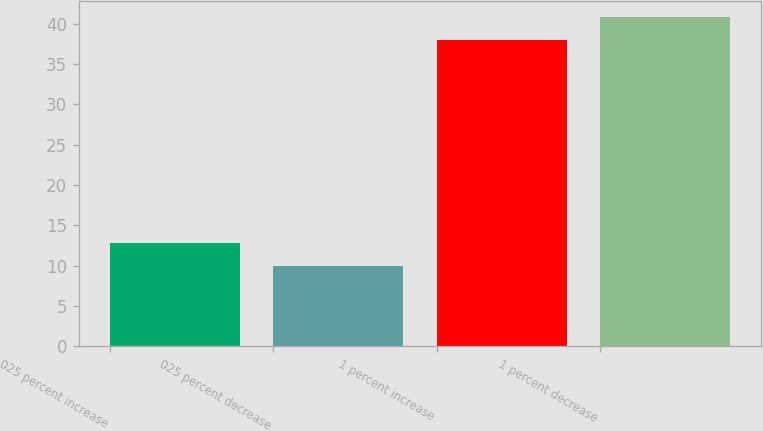Convert chart to OTSL. <chart><loc_0><loc_0><loc_500><loc_500><bar_chart><fcel>025 percent increase<fcel>025 percent decrease<fcel>1 percent increase<fcel>1 percent decrease<nl><fcel>12.8<fcel>10<fcel>38<fcel>40.8<nl></chart> 